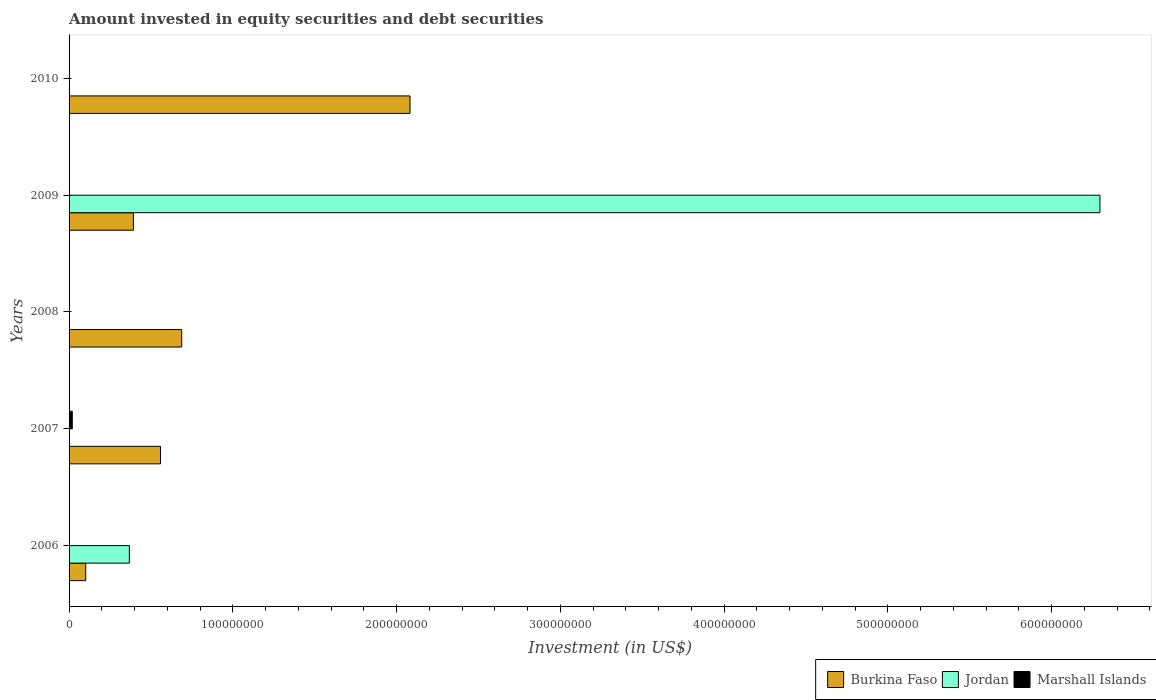How many different coloured bars are there?
Your answer should be compact. 3. Are the number of bars per tick equal to the number of legend labels?
Your answer should be compact. No. Are the number of bars on each tick of the Y-axis equal?
Ensure brevity in your answer.  No. How many bars are there on the 1st tick from the top?
Make the answer very short. 1. How many bars are there on the 3rd tick from the bottom?
Ensure brevity in your answer.  1. What is the amount invested in equity securities and debt securities in Burkina Faso in 2010?
Provide a succinct answer. 2.08e+08. Across all years, what is the maximum amount invested in equity securities and debt securities in Jordan?
Your answer should be compact. 6.30e+08. Across all years, what is the minimum amount invested in equity securities and debt securities in Burkina Faso?
Offer a terse response. 1.02e+07. In which year was the amount invested in equity securities and debt securities in Burkina Faso maximum?
Make the answer very short. 2010. What is the total amount invested in equity securities and debt securities in Marshall Islands in the graph?
Provide a short and direct response. 1.97e+06. What is the difference between the amount invested in equity securities and debt securities in Jordan in 2006 and that in 2009?
Your answer should be compact. -5.93e+08. What is the difference between the amount invested in equity securities and debt securities in Jordan in 2010 and the amount invested in equity securities and debt securities in Burkina Faso in 2008?
Provide a succinct answer. -6.88e+07. What is the average amount invested in equity securities and debt securities in Marshall Islands per year?
Your answer should be compact. 3.93e+05. What is the ratio of the amount invested in equity securities and debt securities in Burkina Faso in 2007 to that in 2010?
Offer a very short reply. 0.27. What is the difference between the highest and the second highest amount invested in equity securities and debt securities in Burkina Faso?
Your answer should be very brief. 1.39e+08. What is the difference between the highest and the lowest amount invested in equity securities and debt securities in Burkina Faso?
Make the answer very short. 1.98e+08. In how many years, is the amount invested in equity securities and debt securities in Marshall Islands greater than the average amount invested in equity securities and debt securities in Marshall Islands taken over all years?
Your answer should be compact. 1. How many bars are there?
Make the answer very short. 8. Does the graph contain any zero values?
Your answer should be compact. Yes. Does the graph contain grids?
Provide a short and direct response. No. Where does the legend appear in the graph?
Give a very brief answer. Bottom right. How are the legend labels stacked?
Make the answer very short. Horizontal. What is the title of the graph?
Ensure brevity in your answer.  Amount invested in equity securities and debt securities. What is the label or title of the X-axis?
Provide a succinct answer. Investment (in US$). What is the label or title of the Y-axis?
Offer a terse response. Years. What is the Investment (in US$) of Burkina Faso in 2006?
Your answer should be very brief. 1.02e+07. What is the Investment (in US$) of Jordan in 2006?
Ensure brevity in your answer.  3.68e+07. What is the Investment (in US$) in Burkina Faso in 2007?
Keep it short and to the point. 5.58e+07. What is the Investment (in US$) of Marshall Islands in 2007?
Give a very brief answer. 1.97e+06. What is the Investment (in US$) in Burkina Faso in 2008?
Your answer should be compact. 6.88e+07. What is the Investment (in US$) of Jordan in 2008?
Offer a very short reply. 0. What is the Investment (in US$) of Marshall Islands in 2008?
Your answer should be very brief. 0. What is the Investment (in US$) of Burkina Faso in 2009?
Keep it short and to the point. 3.93e+07. What is the Investment (in US$) in Jordan in 2009?
Offer a very short reply. 6.30e+08. What is the Investment (in US$) in Marshall Islands in 2009?
Ensure brevity in your answer.  0. What is the Investment (in US$) in Burkina Faso in 2010?
Your response must be concise. 2.08e+08. What is the Investment (in US$) in Jordan in 2010?
Keep it short and to the point. 0. Across all years, what is the maximum Investment (in US$) of Burkina Faso?
Make the answer very short. 2.08e+08. Across all years, what is the maximum Investment (in US$) in Jordan?
Ensure brevity in your answer.  6.30e+08. Across all years, what is the maximum Investment (in US$) of Marshall Islands?
Make the answer very short. 1.97e+06. Across all years, what is the minimum Investment (in US$) of Burkina Faso?
Your response must be concise. 1.02e+07. Across all years, what is the minimum Investment (in US$) in Jordan?
Your answer should be compact. 0. Across all years, what is the minimum Investment (in US$) of Marshall Islands?
Ensure brevity in your answer.  0. What is the total Investment (in US$) in Burkina Faso in the graph?
Provide a succinct answer. 3.82e+08. What is the total Investment (in US$) of Jordan in the graph?
Your answer should be compact. 6.66e+08. What is the total Investment (in US$) in Marshall Islands in the graph?
Your answer should be very brief. 1.97e+06. What is the difference between the Investment (in US$) of Burkina Faso in 2006 and that in 2007?
Your answer should be very brief. -4.57e+07. What is the difference between the Investment (in US$) in Burkina Faso in 2006 and that in 2008?
Give a very brief answer. -5.86e+07. What is the difference between the Investment (in US$) in Burkina Faso in 2006 and that in 2009?
Give a very brief answer. -2.91e+07. What is the difference between the Investment (in US$) of Jordan in 2006 and that in 2009?
Keep it short and to the point. -5.93e+08. What is the difference between the Investment (in US$) in Burkina Faso in 2006 and that in 2010?
Your answer should be compact. -1.98e+08. What is the difference between the Investment (in US$) in Burkina Faso in 2007 and that in 2008?
Keep it short and to the point. -1.29e+07. What is the difference between the Investment (in US$) of Burkina Faso in 2007 and that in 2009?
Provide a short and direct response. 1.65e+07. What is the difference between the Investment (in US$) of Burkina Faso in 2007 and that in 2010?
Your response must be concise. -1.52e+08. What is the difference between the Investment (in US$) of Burkina Faso in 2008 and that in 2009?
Give a very brief answer. 2.95e+07. What is the difference between the Investment (in US$) in Burkina Faso in 2008 and that in 2010?
Your answer should be compact. -1.39e+08. What is the difference between the Investment (in US$) of Burkina Faso in 2009 and that in 2010?
Offer a very short reply. -1.69e+08. What is the difference between the Investment (in US$) in Burkina Faso in 2006 and the Investment (in US$) in Marshall Islands in 2007?
Your response must be concise. 8.19e+06. What is the difference between the Investment (in US$) in Jordan in 2006 and the Investment (in US$) in Marshall Islands in 2007?
Offer a terse response. 3.48e+07. What is the difference between the Investment (in US$) in Burkina Faso in 2006 and the Investment (in US$) in Jordan in 2009?
Your answer should be very brief. -6.19e+08. What is the difference between the Investment (in US$) of Burkina Faso in 2007 and the Investment (in US$) of Jordan in 2009?
Make the answer very short. -5.74e+08. What is the difference between the Investment (in US$) of Burkina Faso in 2008 and the Investment (in US$) of Jordan in 2009?
Provide a succinct answer. -5.61e+08. What is the average Investment (in US$) in Burkina Faso per year?
Provide a succinct answer. 7.65e+07. What is the average Investment (in US$) in Jordan per year?
Your response must be concise. 1.33e+08. What is the average Investment (in US$) in Marshall Islands per year?
Give a very brief answer. 3.93e+05. In the year 2006, what is the difference between the Investment (in US$) in Burkina Faso and Investment (in US$) in Jordan?
Make the answer very short. -2.67e+07. In the year 2007, what is the difference between the Investment (in US$) of Burkina Faso and Investment (in US$) of Marshall Islands?
Your response must be concise. 5.39e+07. In the year 2009, what is the difference between the Investment (in US$) in Burkina Faso and Investment (in US$) in Jordan?
Your answer should be very brief. -5.90e+08. What is the ratio of the Investment (in US$) in Burkina Faso in 2006 to that in 2007?
Make the answer very short. 0.18. What is the ratio of the Investment (in US$) of Burkina Faso in 2006 to that in 2008?
Make the answer very short. 0.15. What is the ratio of the Investment (in US$) of Burkina Faso in 2006 to that in 2009?
Offer a very short reply. 0.26. What is the ratio of the Investment (in US$) of Jordan in 2006 to that in 2009?
Give a very brief answer. 0.06. What is the ratio of the Investment (in US$) in Burkina Faso in 2006 to that in 2010?
Ensure brevity in your answer.  0.05. What is the ratio of the Investment (in US$) in Burkina Faso in 2007 to that in 2008?
Give a very brief answer. 0.81. What is the ratio of the Investment (in US$) of Burkina Faso in 2007 to that in 2009?
Keep it short and to the point. 1.42. What is the ratio of the Investment (in US$) in Burkina Faso in 2007 to that in 2010?
Your answer should be very brief. 0.27. What is the ratio of the Investment (in US$) in Burkina Faso in 2008 to that in 2009?
Keep it short and to the point. 1.75. What is the ratio of the Investment (in US$) of Burkina Faso in 2008 to that in 2010?
Make the answer very short. 0.33. What is the ratio of the Investment (in US$) of Burkina Faso in 2009 to that in 2010?
Your response must be concise. 0.19. What is the difference between the highest and the second highest Investment (in US$) in Burkina Faso?
Make the answer very short. 1.39e+08. What is the difference between the highest and the lowest Investment (in US$) in Burkina Faso?
Offer a very short reply. 1.98e+08. What is the difference between the highest and the lowest Investment (in US$) of Jordan?
Provide a short and direct response. 6.30e+08. What is the difference between the highest and the lowest Investment (in US$) in Marshall Islands?
Give a very brief answer. 1.97e+06. 